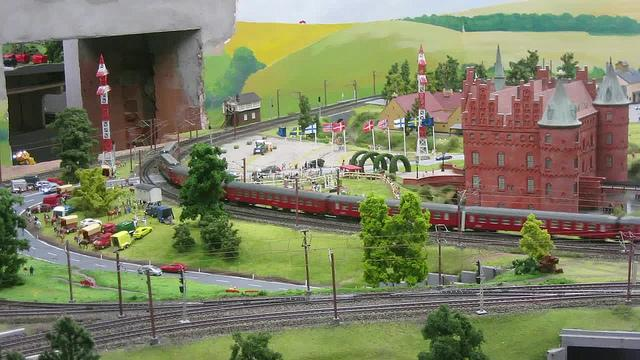Why does the background seem so flat and odd what type train scene does this signify that this is? Please explain your reasoning. model train. The scene is painted onto a wall and the whole set up is a miniature version of the "real thing". 